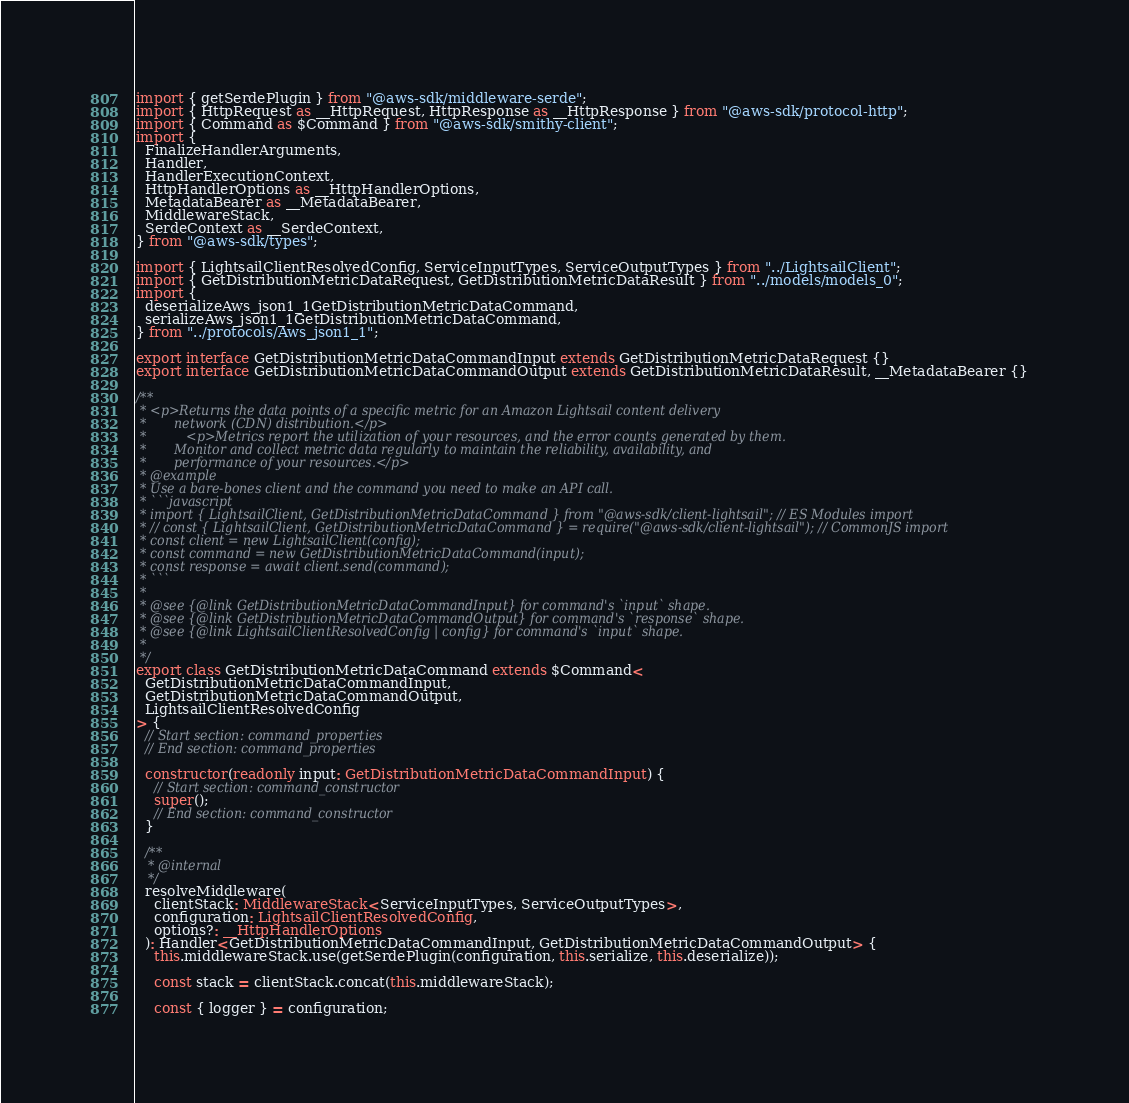Convert code to text. <code><loc_0><loc_0><loc_500><loc_500><_TypeScript_>import { getSerdePlugin } from "@aws-sdk/middleware-serde";
import { HttpRequest as __HttpRequest, HttpResponse as __HttpResponse } from "@aws-sdk/protocol-http";
import { Command as $Command } from "@aws-sdk/smithy-client";
import {
  FinalizeHandlerArguments,
  Handler,
  HandlerExecutionContext,
  HttpHandlerOptions as __HttpHandlerOptions,
  MetadataBearer as __MetadataBearer,
  MiddlewareStack,
  SerdeContext as __SerdeContext,
} from "@aws-sdk/types";

import { LightsailClientResolvedConfig, ServiceInputTypes, ServiceOutputTypes } from "../LightsailClient";
import { GetDistributionMetricDataRequest, GetDistributionMetricDataResult } from "../models/models_0";
import {
  deserializeAws_json1_1GetDistributionMetricDataCommand,
  serializeAws_json1_1GetDistributionMetricDataCommand,
} from "../protocols/Aws_json1_1";

export interface GetDistributionMetricDataCommandInput extends GetDistributionMetricDataRequest {}
export interface GetDistributionMetricDataCommandOutput extends GetDistributionMetricDataResult, __MetadataBearer {}

/**
 * <p>Returns the data points of a specific metric for an Amazon Lightsail content delivery
 *       network (CDN) distribution.</p>
 *          <p>Metrics report the utilization of your resources, and the error counts generated by them.
 *       Monitor and collect metric data regularly to maintain the reliability, availability, and
 *       performance of your resources.</p>
 * @example
 * Use a bare-bones client and the command you need to make an API call.
 * ```javascript
 * import { LightsailClient, GetDistributionMetricDataCommand } from "@aws-sdk/client-lightsail"; // ES Modules import
 * // const { LightsailClient, GetDistributionMetricDataCommand } = require("@aws-sdk/client-lightsail"); // CommonJS import
 * const client = new LightsailClient(config);
 * const command = new GetDistributionMetricDataCommand(input);
 * const response = await client.send(command);
 * ```
 *
 * @see {@link GetDistributionMetricDataCommandInput} for command's `input` shape.
 * @see {@link GetDistributionMetricDataCommandOutput} for command's `response` shape.
 * @see {@link LightsailClientResolvedConfig | config} for command's `input` shape.
 *
 */
export class GetDistributionMetricDataCommand extends $Command<
  GetDistributionMetricDataCommandInput,
  GetDistributionMetricDataCommandOutput,
  LightsailClientResolvedConfig
> {
  // Start section: command_properties
  // End section: command_properties

  constructor(readonly input: GetDistributionMetricDataCommandInput) {
    // Start section: command_constructor
    super();
    // End section: command_constructor
  }

  /**
   * @internal
   */
  resolveMiddleware(
    clientStack: MiddlewareStack<ServiceInputTypes, ServiceOutputTypes>,
    configuration: LightsailClientResolvedConfig,
    options?: __HttpHandlerOptions
  ): Handler<GetDistributionMetricDataCommandInput, GetDistributionMetricDataCommandOutput> {
    this.middlewareStack.use(getSerdePlugin(configuration, this.serialize, this.deserialize));

    const stack = clientStack.concat(this.middlewareStack);

    const { logger } = configuration;</code> 